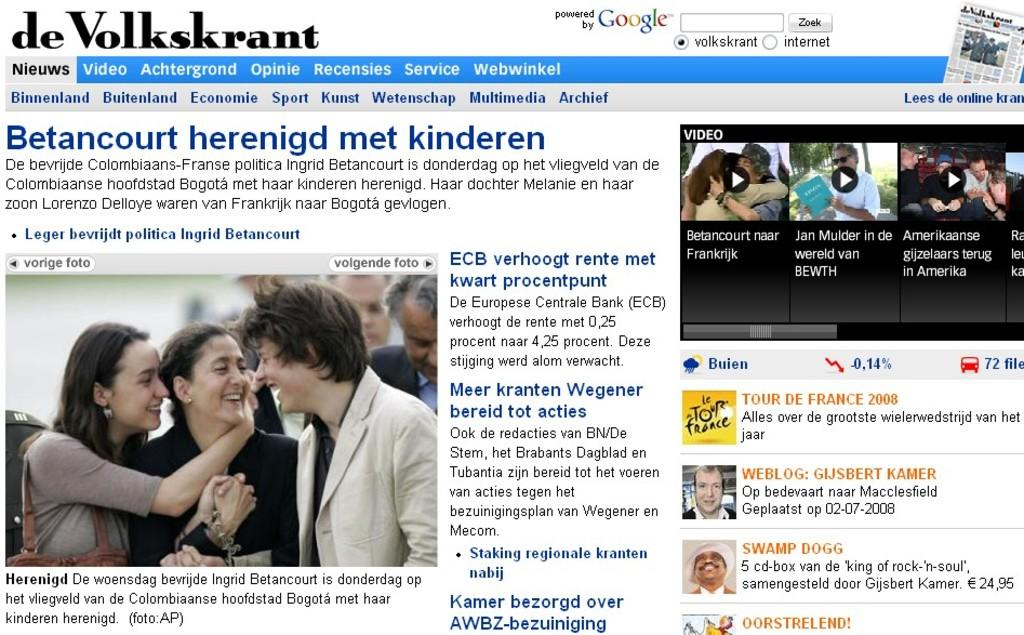What type of content is present on the web page? There is text and pictures of people on the web page. Can you describe the people in the pictures? Some people in the pictures are holding objects. What is the cause of the argument between the people in the pictures? There is no argument present in the images; the people in the pictures are simply holding objects. 